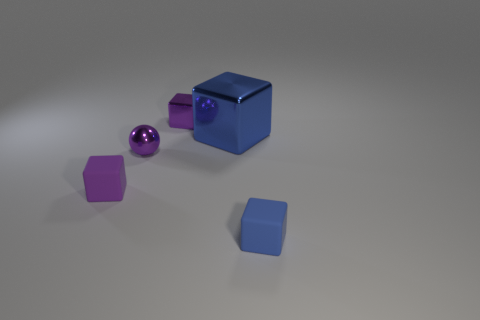How many other objects are the same size as the sphere?
Make the answer very short. 3. Is the shape of the rubber object on the left side of the shiny sphere the same as  the blue metal object?
Ensure brevity in your answer.  Yes. There is a small metal thing that is the same shape as the big blue metal object; what is its color?
Your response must be concise. Purple. Are there any other things that have the same shape as the purple matte thing?
Offer a very short reply. Yes. Is the number of purple matte objects to the left of the purple matte cube the same as the number of tiny gray rubber cylinders?
Offer a very short reply. Yes. How many blue things are both in front of the small purple rubber object and to the left of the small blue block?
Your response must be concise. 0. What is the size of the purple matte object that is the same shape as the blue rubber object?
Provide a short and direct response. Small. How many other objects are made of the same material as the large blue thing?
Keep it short and to the point. 2. Is the number of metal spheres on the left side of the blue metal object less than the number of small blue things?
Offer a very short reply. No. What number of big blue matte objects are there?
Offer a very short reply. 0. 